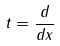<formula> <loc_0><loc_0><loc_500><loc_500>t = \frac { d } { d x }</formula> 